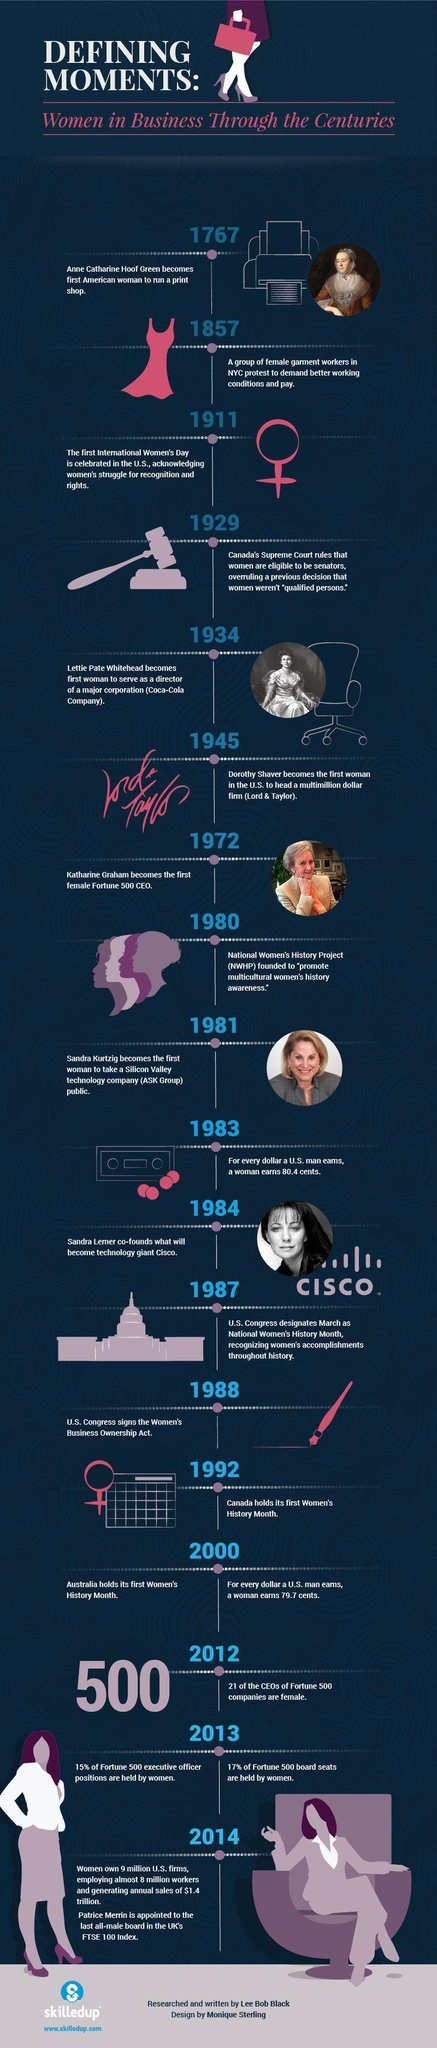When was the first International Women's day celebrated in the U.S.?
Answer the question with a short phrase. 1911 Who is the co-founder of Cisco systems? Sandra Lerner When did U.S. Congress signed the Women's Business Ownership Act? 1988 When did Katharine Graham became the first female CEO of a Fortune 500 company? 1972 